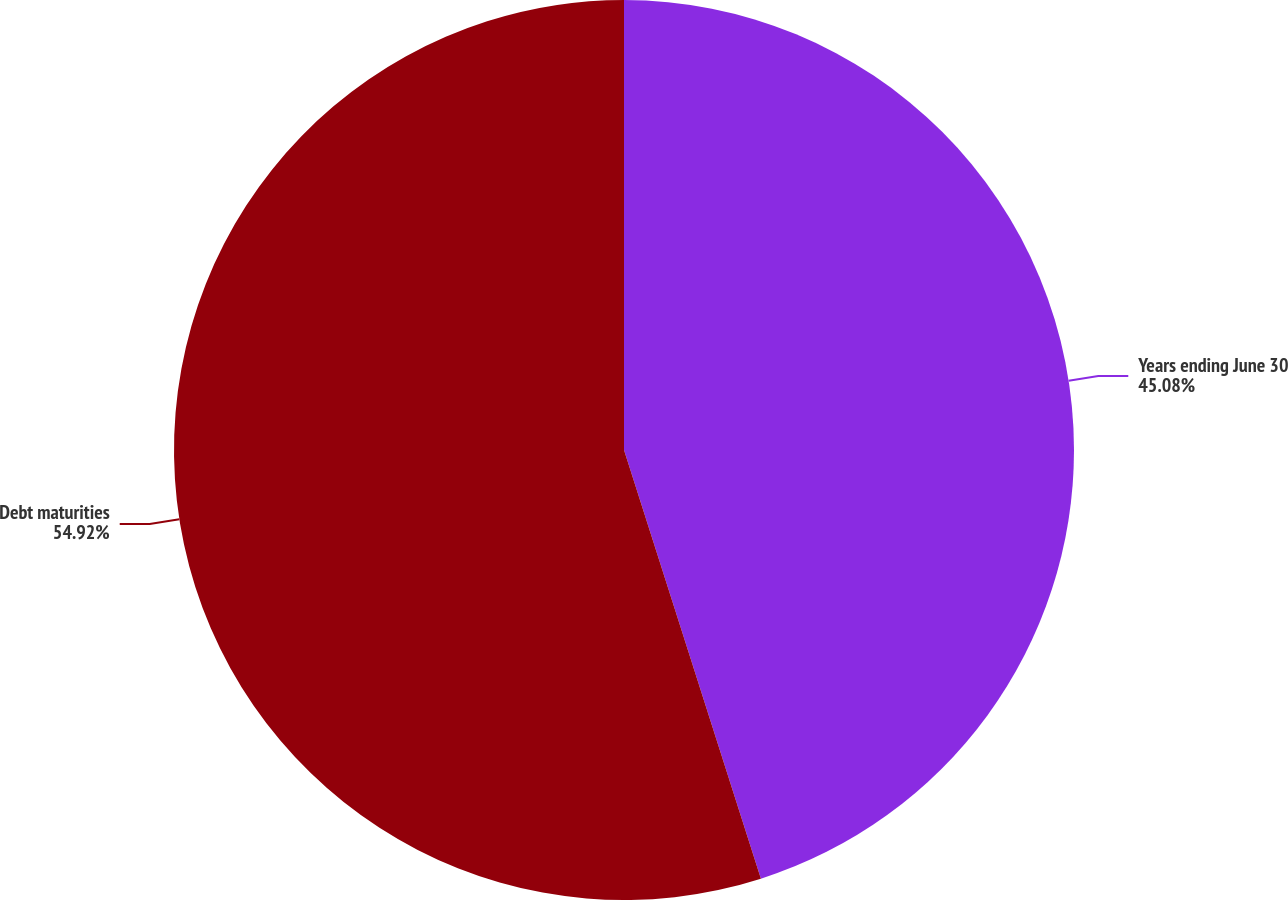<chart> <loc_0><loc_0><loc_500><loc_500><pie_chart><fcel>Years ending June 30<fcel>Debt maturities<nl><fcel>45.08%<fcel>54.92%<nl></chart> 